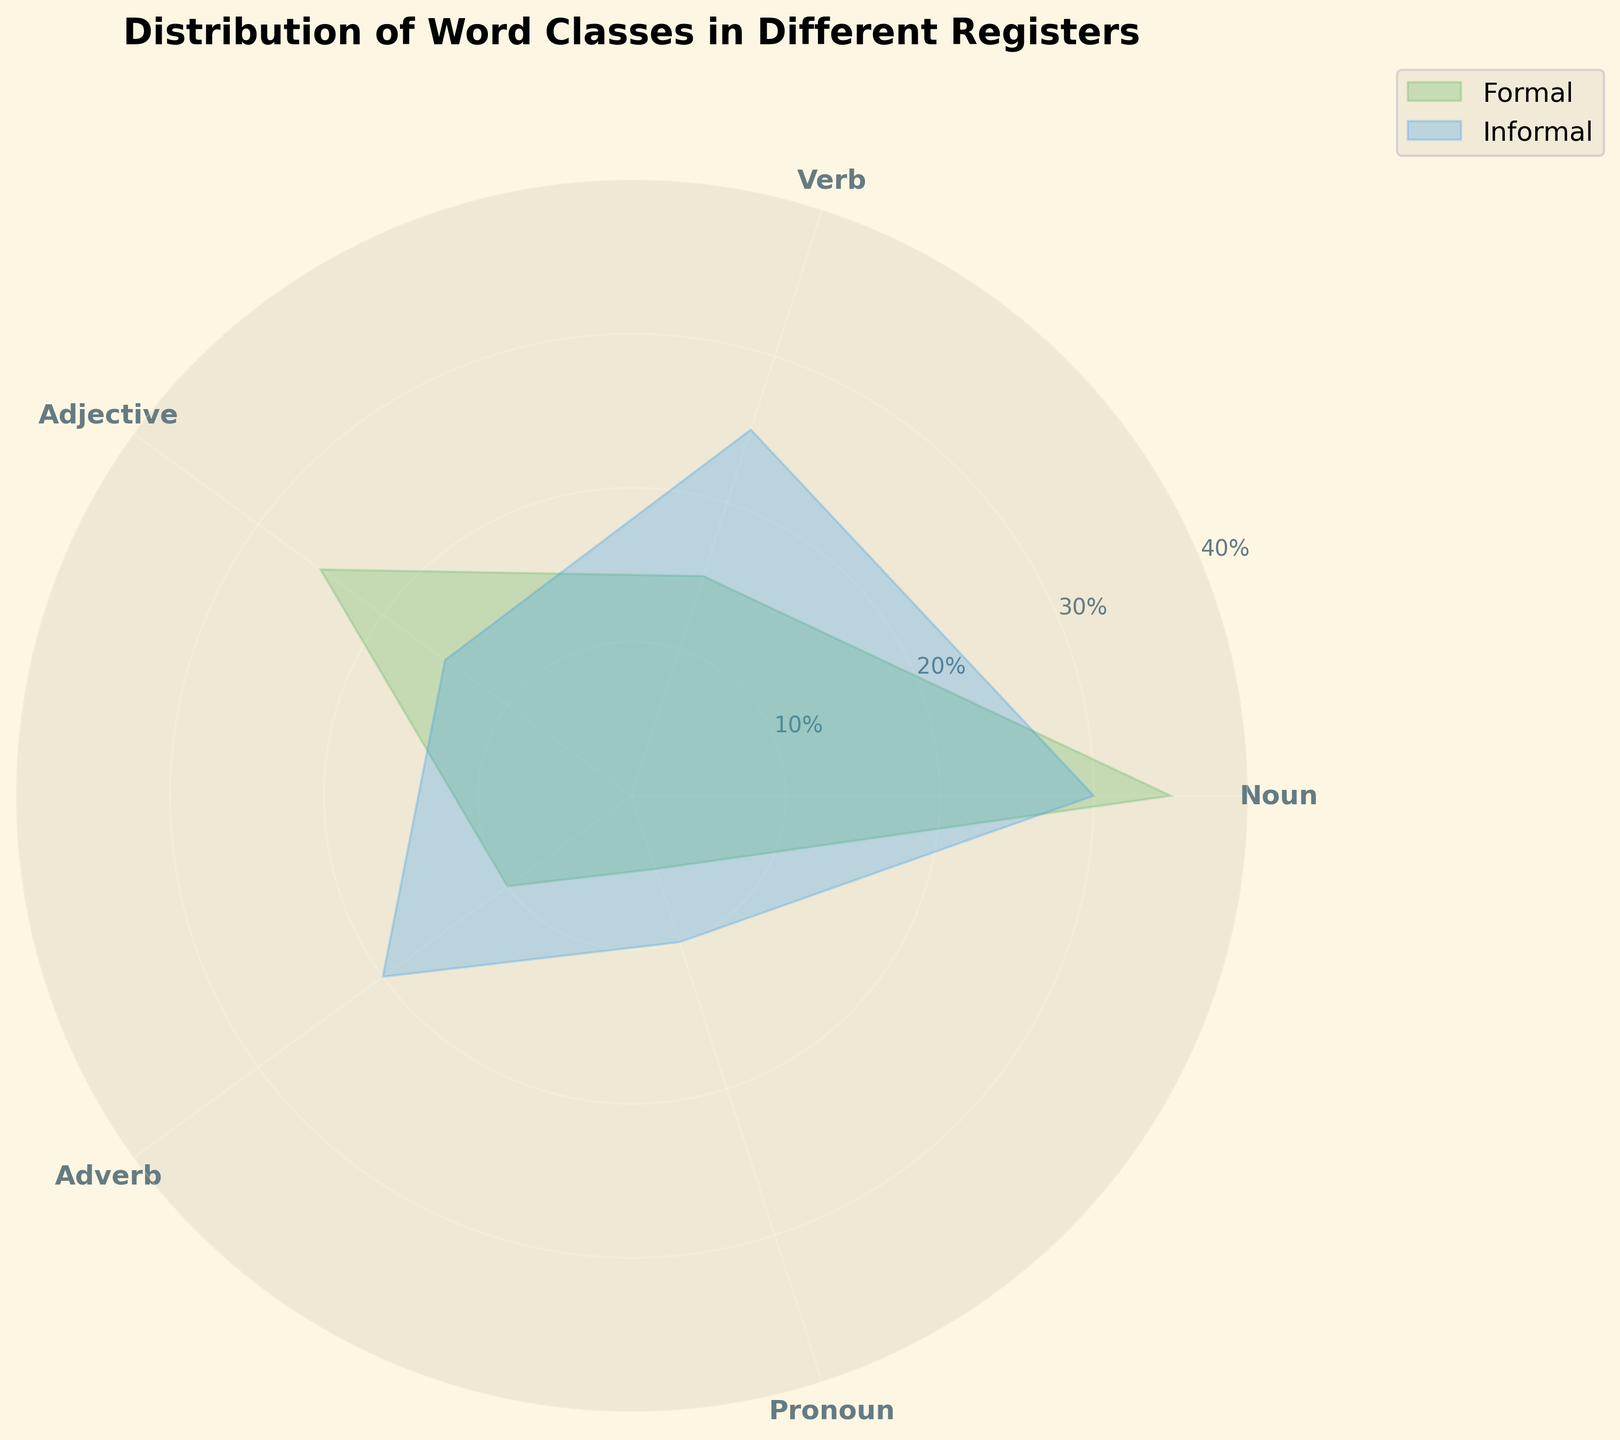What are the two registers compared in the chart? The title of the plot is "Distribution of Word Classes in Different Registers," and the legend shows two labeled areas: Formal and Informal.
Answer: Formal and Informal Which word class has the highest frequency in the Formal register? By comparing the radial lengths of each word class in the Formal register, which is represented by the green (lighter color) filled area, the Noun category reaches the highest point.
Answer: Noun Which register uses adjectives more frequently? Observing the lengths of the segments labeled 'Adjective' for both the Formal (green/lighter) and Informal (blue/darker) areas, the Formal register extends further out.
Answer: Formal How many word classes have a frequency of 25 or more in the Informal register? By examining the lengths of the radial segments for the Informal register, the blue (darker) area in 'Noun' and 'Verb' classes extends to or beyond the 25 mark.
Answer: Two What is the difference in frequency of nouns between the formal and informal registers? The radial length for informal nouns reaches 30, while the length for formal nouns reaches 35. Subtracting these gives a difference of 5.
Answer: 5 Which register uses pronouns the least? Observing the lengths of the segments labeled 'Pronoun' for both registers, the Formal register's (green/lighter) segment is shorter.
Answer: Formal By how much does the frequency of verbs differ between the formal and informal registers? The length of the 'Verb' segment in the Formal register is 15, while in the Informal register it is 25. Subtracting these gives a difference of 10.
Answer: 10 What is the total frequency of adjectives and adverbs in the Informal register? In the Informal register, the frequencies for 'Adjective' and 'Adverb' are 15 and 20, respectively. Their sum is 15 + 20 = 35.
Answer: 35 Which register has a higher total frequency for the word classes shown in the chart? Summing up all the segments for the Formal register yields 35 (Noun) + 15 (Verb) + 25 (Adjective) + 10 (Adverb) + 5 (Pronoun) = 90. For the Informal register: 30 + 25 + 15 + 20 + 10 = 100.
Answer: Informal How does the distribution of adverbs compare between Formal and Informal registers? Comparing the 'Adverb' segments, the Formal register's radial length reaches 10 while the Informal register's extends to 20, meaning the Informal register uses adverbs twice as much as the Formal register.
Answer: Informal uses adverbs twice as much 